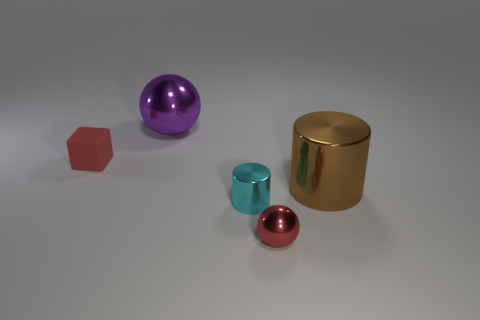Subtract all green cylinders. Subtract all yellow balls. How many cylinders are left? 2 Add 1 purple metallic objects. How many objects exist? 6 Subtract all cubes. How many objects are left? 4 Add 2 small red metallic spheres. How many small red metallic spheres are left? 3 Add 5 small purple metal blocks. How many small purple metal blocks exist? 5 Subtract 0 red cylinders. How many objects are left? 5 Subtract all cyan balls. Subtract all large metallic things. How many objects are left? 3 